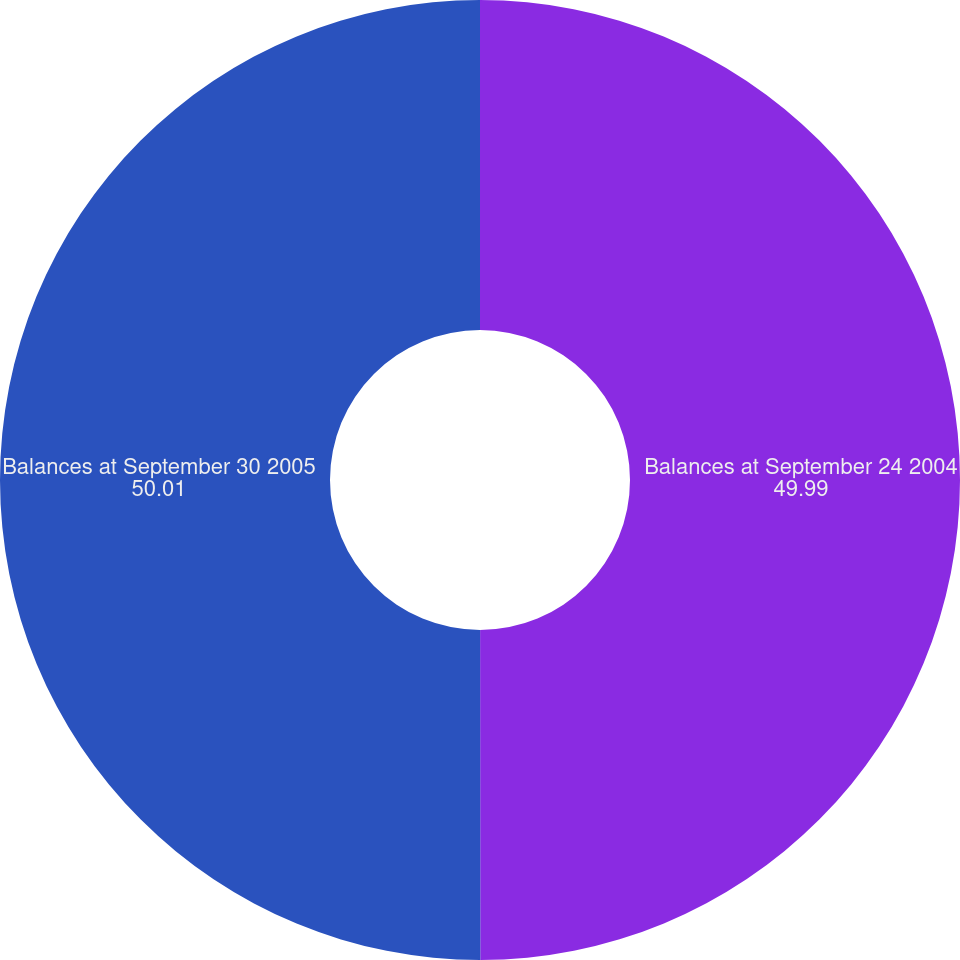Convert chart to OTSL. <chart><loc_0><loc_0><loc_500><loc_500><pie_chart><fcel>Balances at September 24 2004<fcel>Balances at September 30 2005<nl><fcel>49.99%<fcel>50.01%<nl></chart> 